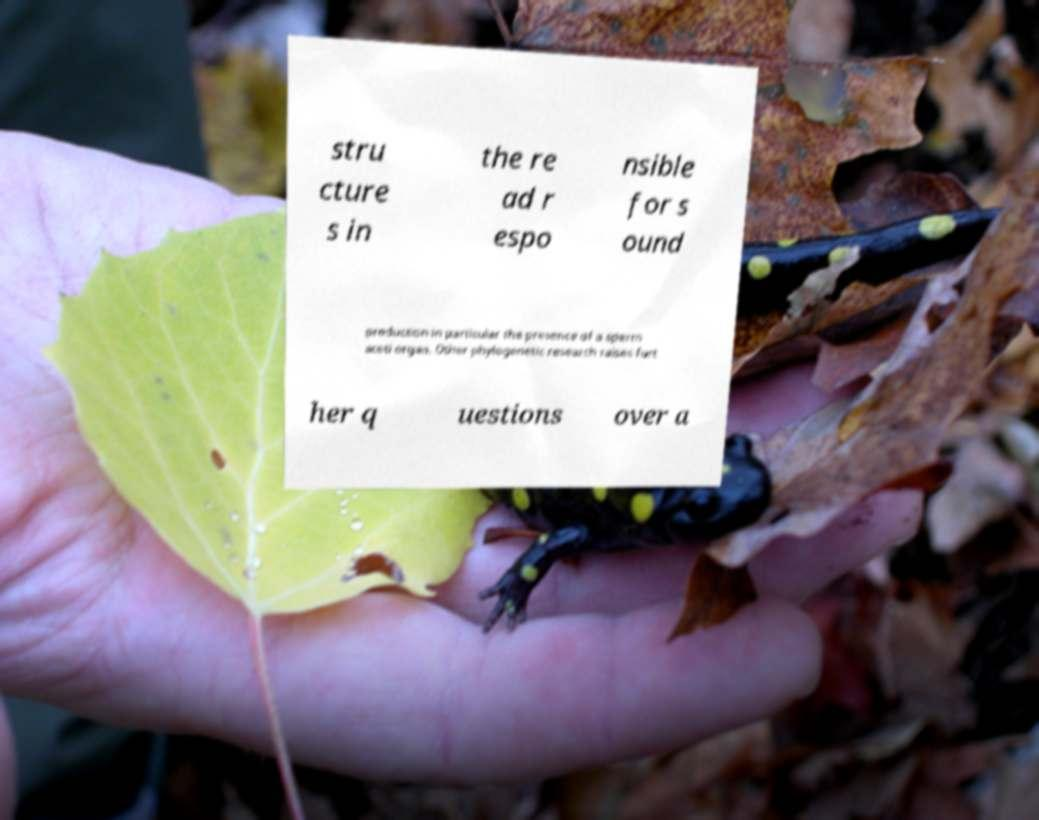Can you read and provide the text displayed in the image?This photo seems to have some interesting text. Can you extract and type it out for me? stru cture s in the re ad r espo nsible for s ound production in particular the presence of a sperm aceti organ. Other phylogenetic research raises furt her q uestions over a 